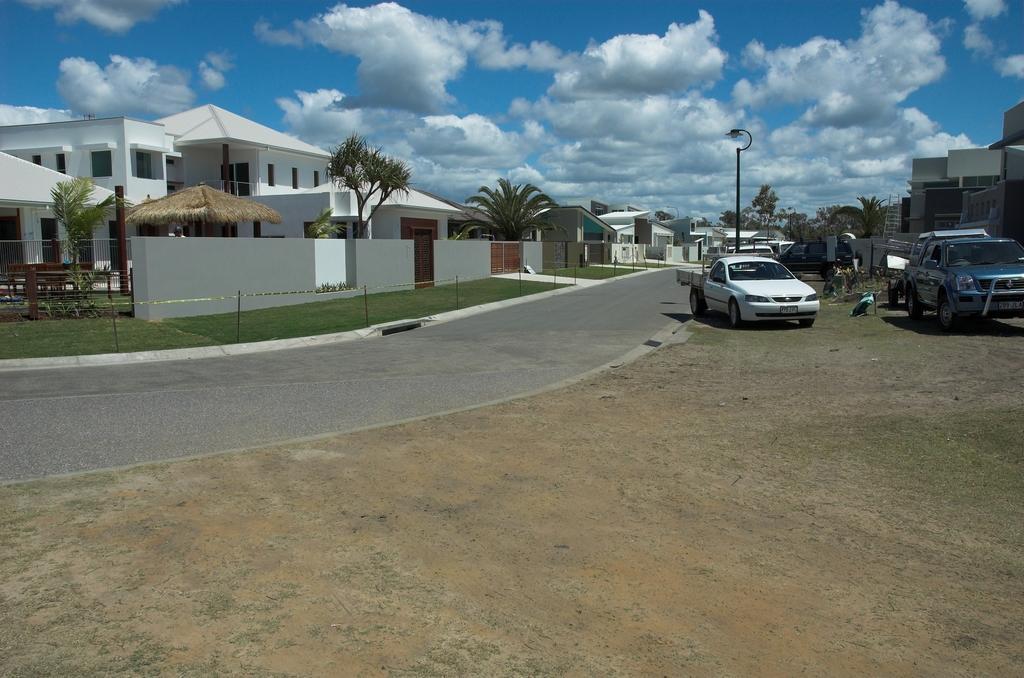Describe this image in one or two sentences. In this image we can see a group of buildings with windows. We can also see a hurt, trees, a fence, some poles tied with a ribbon, the road, a street lamp and some vehicles on the ground. On the backside we can see some trees and the sky which looks cloudy. 